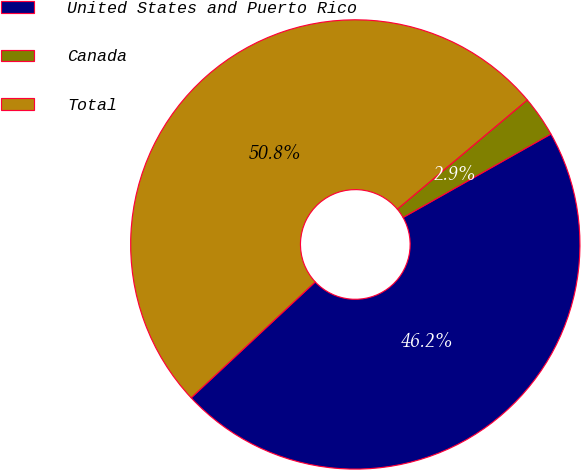Convert chart to OTSL. <chart><loc_0><loc_0><loc_500><loc_500><pie_chart><fcel>United States and Puerto Rico<fcel>Canada<fcel>Total<nl><fcel>46.22%<fcel>2.94%<fcel>50.84%<nl></chart> 